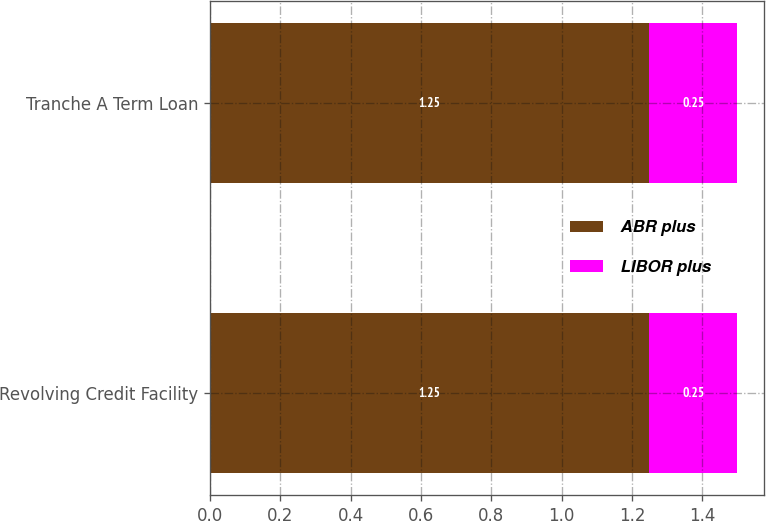Convert chart. <chart><loc_0><loc_0><loc_500><loc_500><stacked_bar_chart><ecel><fcel>Revolving Credit Facility<fcel>Tranche A Term Loan<nl><fcel>ABR plus<fcel>1.25<fcel>1.25<nl><fcel>LIBOR plus<fcel>0.25<fcel>0.25<nl></chart> 